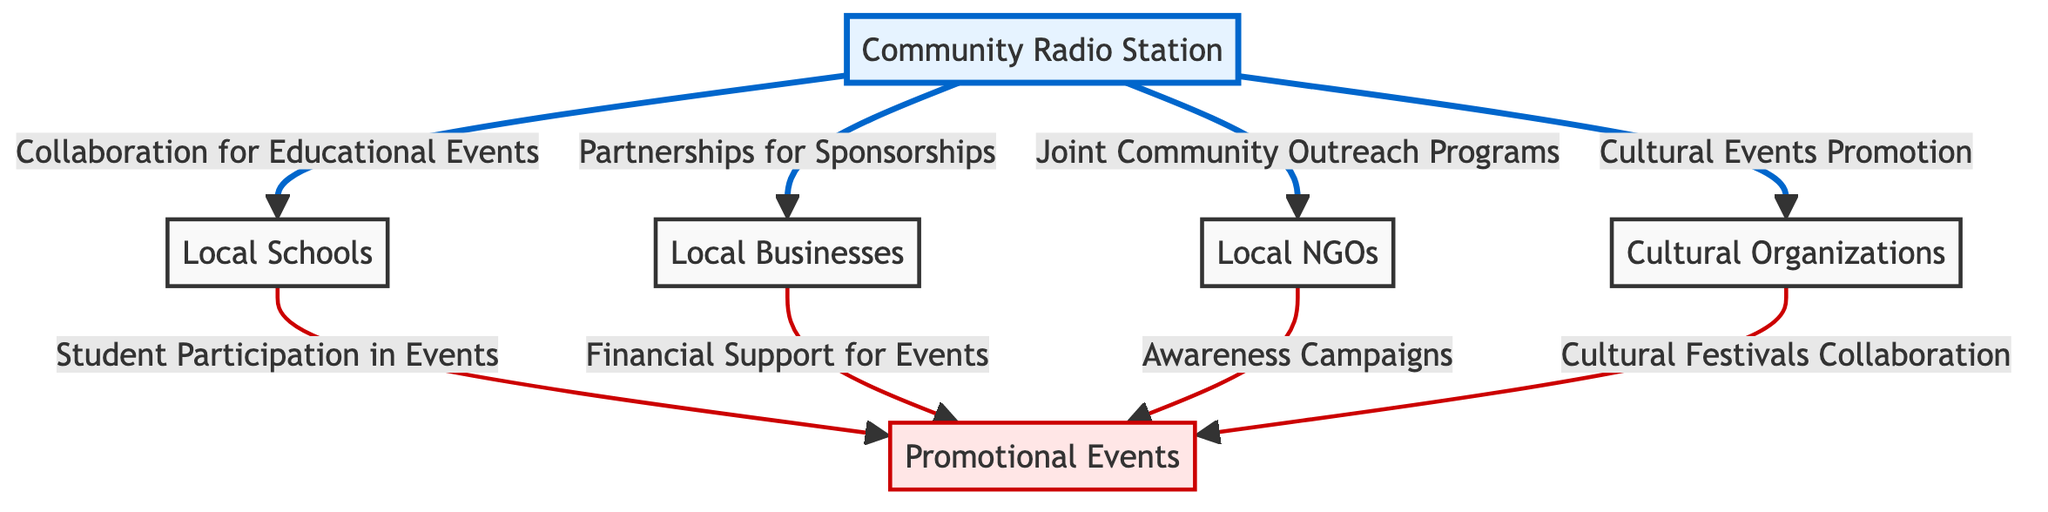What is the total number of nodes in the diagram? Counting the nodes listed, we have Community Radio Station, Local Schools, Local Businesses, Local NGOs, Cultural Organizations, and Promotional Events. This totals to six nodes.
Answer: 6 What is the relationship between Community Radio Station and Local Businesses? The diagram indicates a direct connection from Community Radio Station to Local Businesses with the label "Partnerships for Sponsorships," which outlines the nature of their collaboration.
Answer: Partnerships for Sponsorships Which organization collaborates with the Community Radio Station for cultural events? The diagram shows a direct link from Community Radio Station to Cultural Organizations with the label "Cultural Events Promotion," identifying this organization as a collaborator for cultural events.
Answer: Cultural Organizations How many edges connect to the Promotional Events node? The edges linked to the Promotional Events node are from Local Schools, Local Businesses, NGOs, and Cultural Organizations, providing four different sources of connection.
Answer: 4 What is the primary purpose of the relationship between Community Radio Station and Local Schools? The directional edge from Community Radio Station to Local Schools is labeled "Collaboration for Educational Events," indicating its purpose centered around educational activities.
Answer: Collaboration for Educational Events Which organization is involved in awareness campaigns linked to Promotional Events? The diagram specifies a connection from Local NGOs to Promotional Events with the label "Awareness Campaigns," indicating their involvement in promoting awareness.
Answer: Local NGOs What type of events do Local Schools participate in according to the diagram? The edge connecting Local Schools to Promotional Events is labeled "Student Participation in Events," specifying the type of events they are involved in.
Answer: Student Participation in Events Which organization supports Promotional Events financially? The diagram represents a connection from Local Businesses to Promotional Events with the label "Financial Support for Events," illustrating their role in financially supporting these initiatives.
Answer: Local Businesses How many collaborative activities are associated with the Community Radio Station in this diagram? There are four edges extending from Community Radio Station to Local Schools, Local Businesses, NGOs, and Cultural Organizations, signifying the collaborative activities established.
Answer: 4 